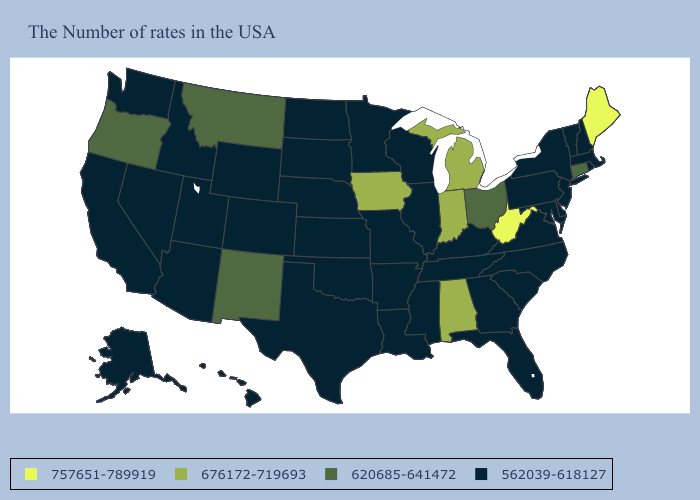What is the value of California?
Write a very short answer. 562039-618127. Among the states that border Kansas , which have the highest value?
Short answer required. Missouri, Nebraska, Oklahoma, Colorado. Among the states that border New Mexico , which have the lowest value?
Write a very short answer. Oklahoma, Texas, Colorado, Utah, Arizona. Among the states that border Alabama , which have the lowest value?
Answer briefly. Florida, Georgia, Tennessee, Mississippi. Among the states that border West Virginia , which have the highest value?
Keep it brief. Ohio. What is the lowest value in the Northeast?
Short answer required. 562039-618127. What is the value of Indiana?
Quick response, please. 676172-719693. What is the highest value in states that border Minnesota?
Concise answer only. 676172-719693. Name the states that have a value in the range 620685-641472?
Be succinct. Connecticut, Ohio, New Mexico, Montana, Oregon. Does the first symbol in the legend represent the smallest category?
Give a very brief answer. No. What is the highest value in the West ?
Keep it brief. 620685-641472. Name the states that have a value in the range 757651-789919?
Write a very short answer. Maine, West Virginia. Among the states that border Wyoming , which have the highest value?
Short answer required. Montana. Does Arizona have a lower value than Arkansas?
Concise answer only. No. What is the value of Vermont?
Short answer required. 562039-618127. 